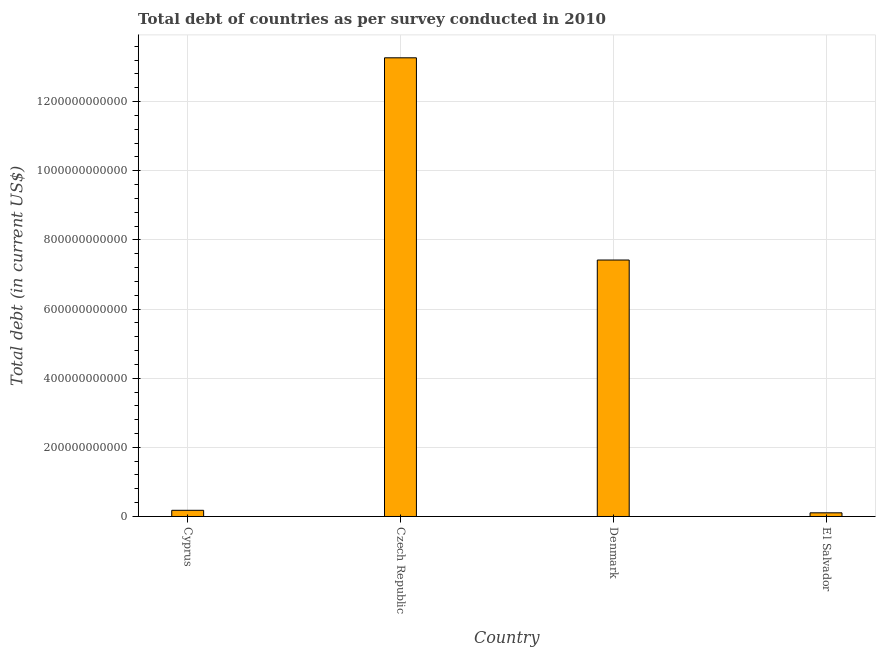Does the graph contain grids?
Provide a short and direct response. Yes. What is the title of the graph?
Offer a terse response. Total debt of countries as per survey conducted in 2010. What is the label or title of the Y-axis?
Offer a terse response. Total debt (in current US$). What is the total debt in Denmark?
Provide a succinct answer. 7.42e+11. Across all countries, what is the maximum total debt?
Make the answer very short. 1.33e+12. Across all countries, what is the minimum total debt?
Offer a terse response. 1.06e+1. In which country was the total debt maximum?
Give a very brief answer. Czech Republic. In which country was the total debt minimum?
Your answer should be compact. El Salvador. What is the sum of the total debt?
Offer a very short reply. 2.10e+12. What is the difference between the total debt in Czech Republic and Denmark?
Provide a succinct answer. 5.85e+11. What is the average total debt per country?
Give a very brief answer. 5.24e+11. What is the median total debt?
Provide a short and direct response. 3.80e+11. In how many countries, is the total debt greater than 360000000000 US$?
Keep it short and to the point. 2. What is the ratio of the total debt in Cyprus to that in Denmark?
Your response must be concise. 0.02. Is the total debt in Cyprus less than that in Denmark?
Offer a terse response. Yes. What is the difference between the highest and the second highest total debt?
Your answer should be very brief. 5.85e+11. Is the sum of the total debt in Cyprus and Czech Republic greater than the maximum total debt across all countries?
Keep it short and to the point. Yes. What is the difference between the highest and the lowest total debt?
Your response must be concise. 1.32e+12. How many bars are there?
Provide a short and direct response. 4. Are all the bars in the graph horizontal?
Your answer should be very brief. No. What is the difference between two consecutive major ticks on the Y-axis?
Ensure brevity in your answer.  2.00e+11. Are the values on the major ticks of Y-axis written in scientific E-notation?
Make the answer very short. No. What is the Total debt (in current US$) in Cyprus?
Ensure brevity in your answer.  1.79e+1. What is the Total debt (in current US$) of Czech Republic?
Provide a succinct answer. 1.33e+12. What is the Total debt (in current US$) in Denmark?
Your answer should be compact. 7.42e+11. What is the Total debt (in current US$) of El Salvador?
Offer a very short reply. 1.06e+1. What is the difference between the Total debt (in current US$) in Cyprus and Czech Republic?
Give a very brief answer. -1.31e+12. What is the difference between the Total debt (in current US$) in Cyprus and Denmark?
Your answer should be very brief. -7.24e+11. What is the difference between the Total debt (in current US$) in Cyprus and El Salvador?
Make the answer very short. 7.28e+09. What is the difference between the Total debt (in current US$) in Czech Republic and Denmark?
Ensure brevity in your answer.  5.85e+11. What is the difference between the Total debt (in current US$) in Czech Republic and El Salvador?
Your answer should be very brief. 1.32e+12. What is the difference between the Total debt (in current US$) in Denmark and El Salvador?
Provide a succinct answer. 7.31e+11. What is the ratio of the Total debt (in current US$) in Cyprus to that in Czech Republic?
Ensure brevity in your answer.  0.01. What is the ratio of the Total debt (in current US$) in Cyprus to that in Denmark?
Make the answer very short. 0.02. What is the ratio of the Total debt (in current US$) in Cyprus to that in El Salvador?
Your answer should be compact. 1.69. What is the ratio of the Total debt (in current US$) in Czech Republic to that in Denmark?
Your response must be concise. 1.79. What is the ratio of the Total debt (in current US$) in Czech Republic to that in El Salvador?
Keep it short and to the point. 125.08. What is the ratio of the Total debt (in current US$) in Denmark to that in El Salvador?
Your answer should be very brief. 69.94. 